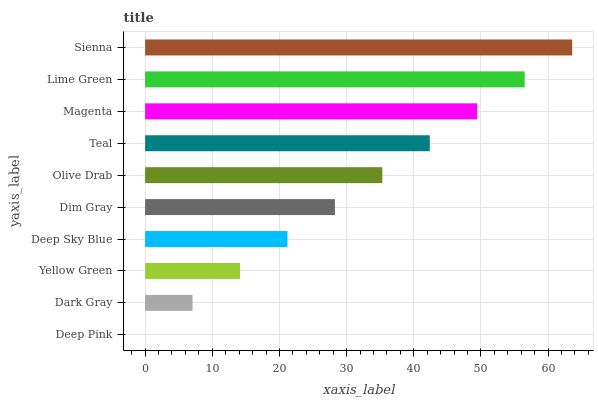Is Deep Pink the minimum?
Answer yes or no. Yes. Is Sienna the maximum?
Answer yes or no. Yes. Is Dark Gray the minimum?
Answer yes or no. No. Is Dark Gray the maximum?
Answer yes or no. No. Is Dark Gray greater than Deep Pink?
Answer yes or no. Yes. Is Deep Pink less than Dark Gray?
Answer yes or no. Yes. Is Deep Pink greater than Dark Gray?
Answer yes or no. No. Is Dark Gray less than Deep Pink?
Answer yes or no. No. Is Olive Drab the high median?
Answer yes or no. Yes. Is Dim Gray the low median?
Answer yes or no. Yes. Is Magenta the high median?
Answer yes or no. No. Is Dark Gray the low median?
Answer yes or no. No. 